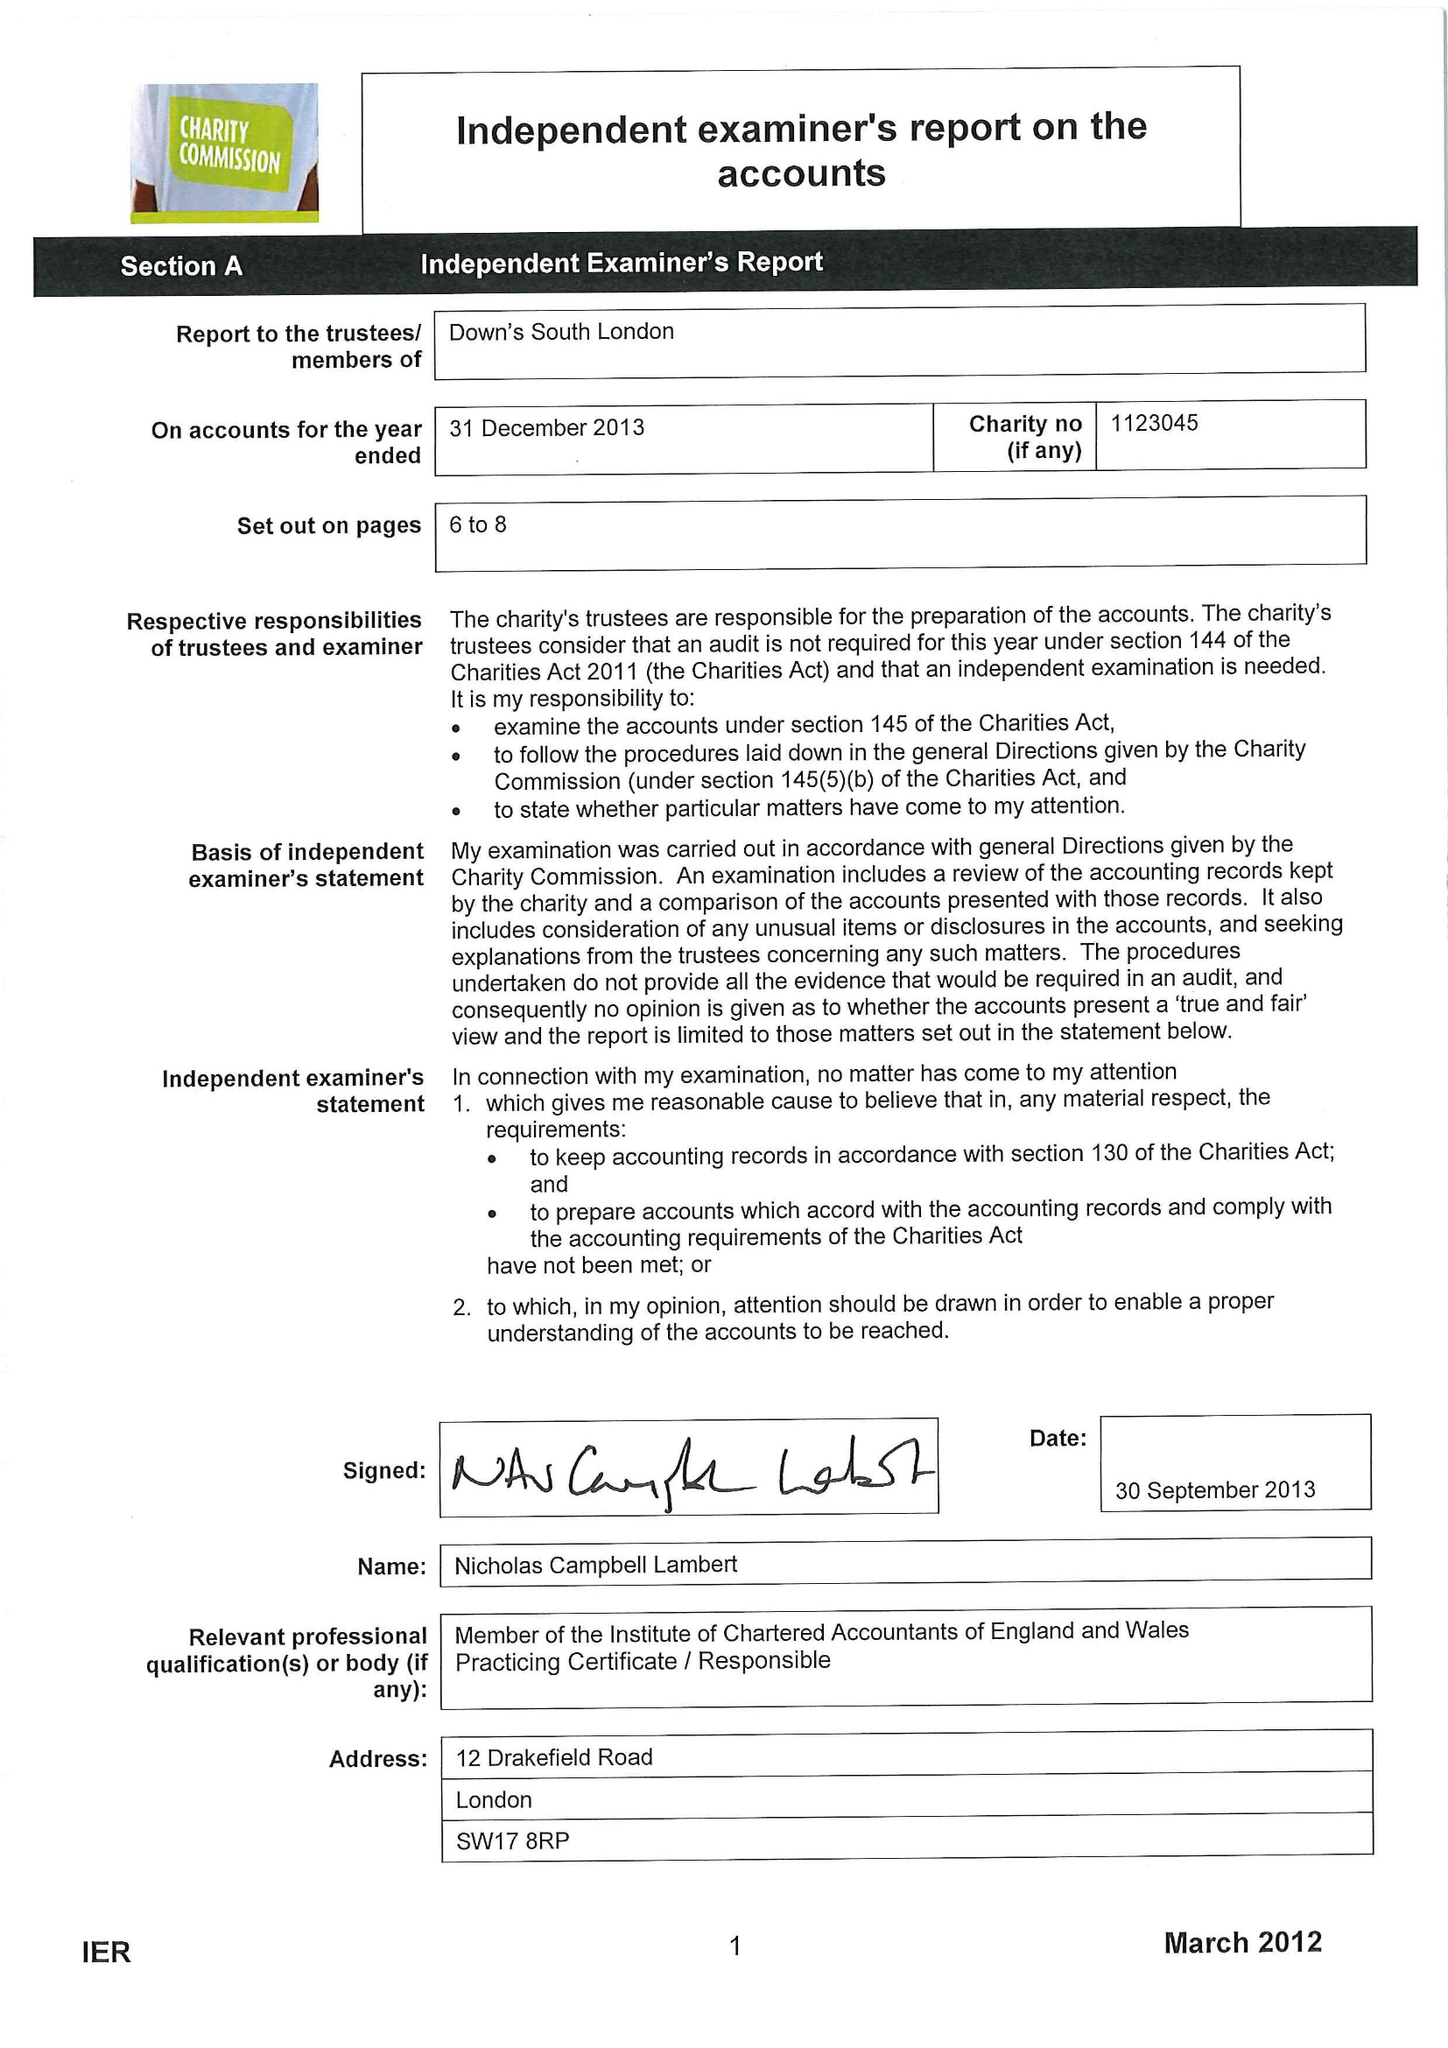What is the value for the address__post_town?
Answer the question using a single word or phrase. LONDON 